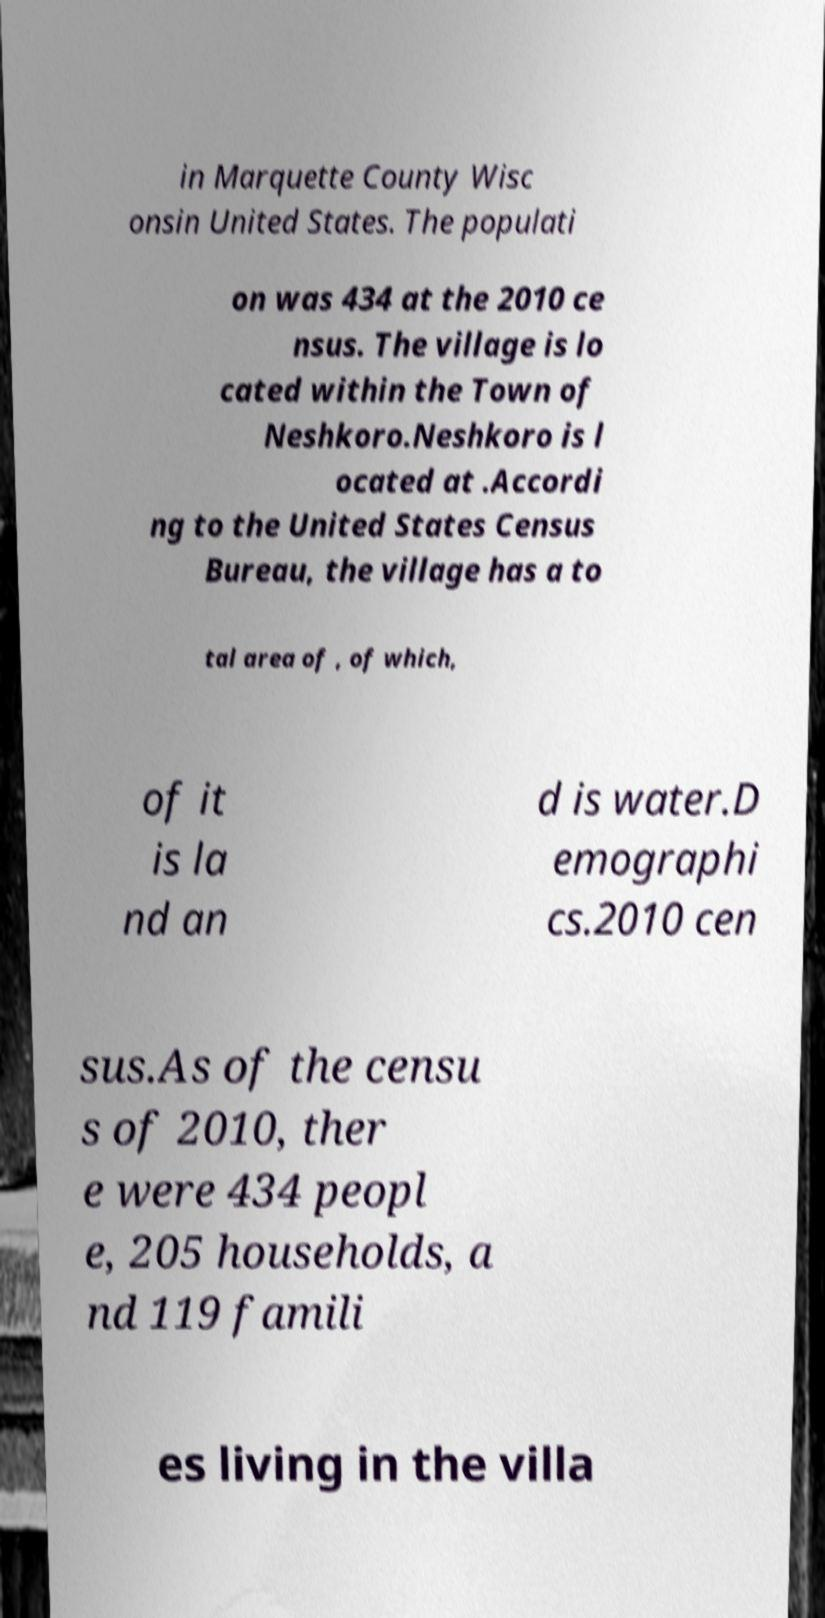Can you read and provide the text displayed in the image?This photo seems to have some interesting text. Can you extract and type it out for me? in Marquette County Wisc onsin United States. The populati on was 434 at the 2010 ce nsus. The village is lo cated within the Town of Neshkoro.Neshkoro is l ocated at .Accordi ng to the United States Census Bureau, the village has a to tal area of , of which, of it is la nd an d is water.D emographi cs.2010 cen sus.As of the censu s of 2010, ther e were 434 peopl e, 205 households, a nd 119 famili es living in the villa 